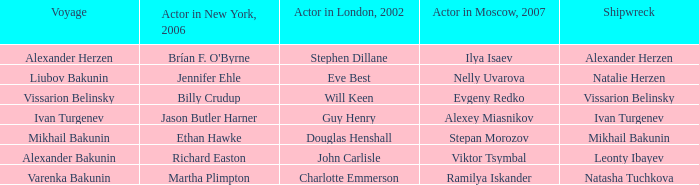Who was the Actor in the New York production in 2006 for the row with Ramilya Iskander performing in Moscow in 2007? Martha Plimpton. 